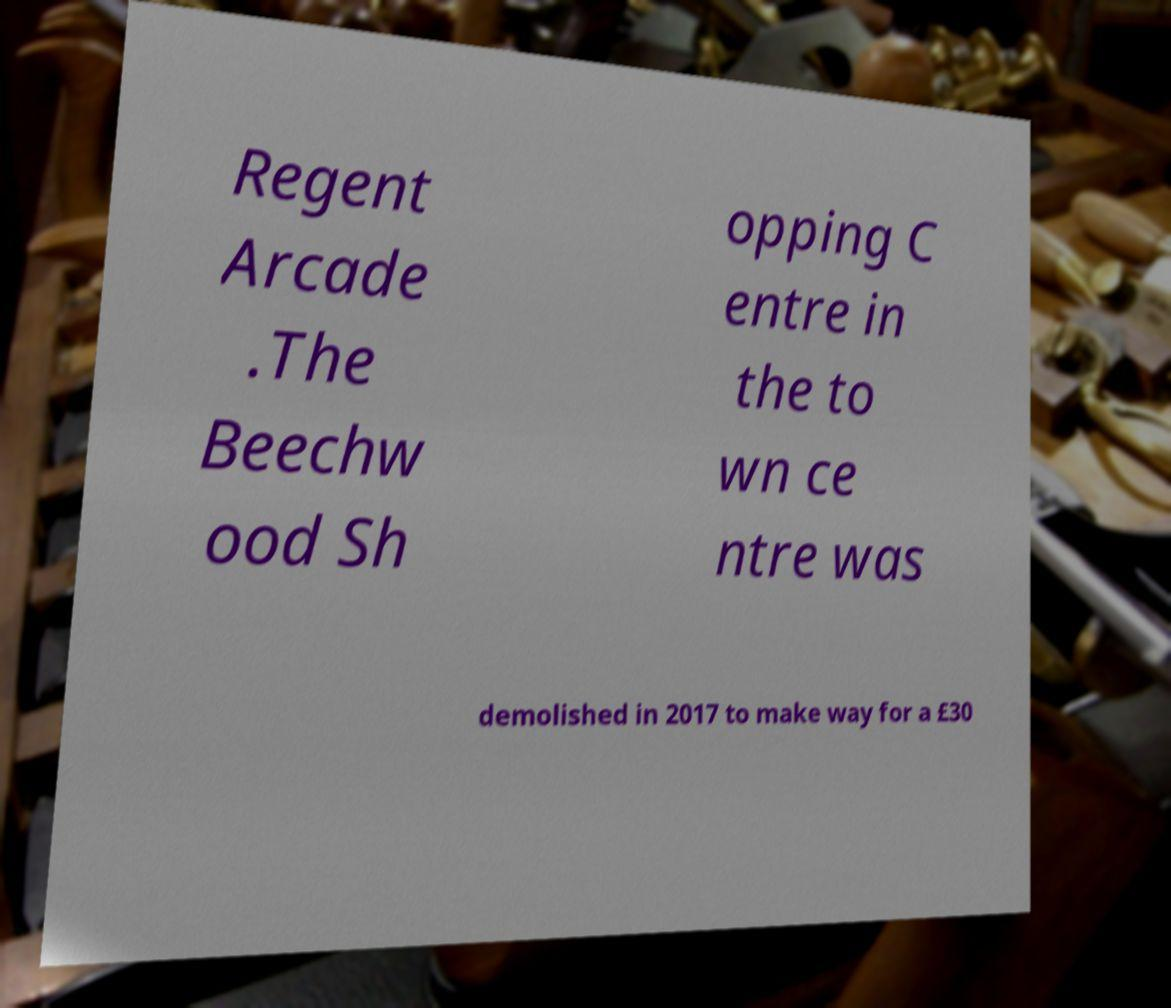Please read and relay the text visible in this image. What does it say? Regent Arcade .The Beechw ood Sh opping C entre in the to wn ce ntre was demolished in 2017 to make way for a £30 